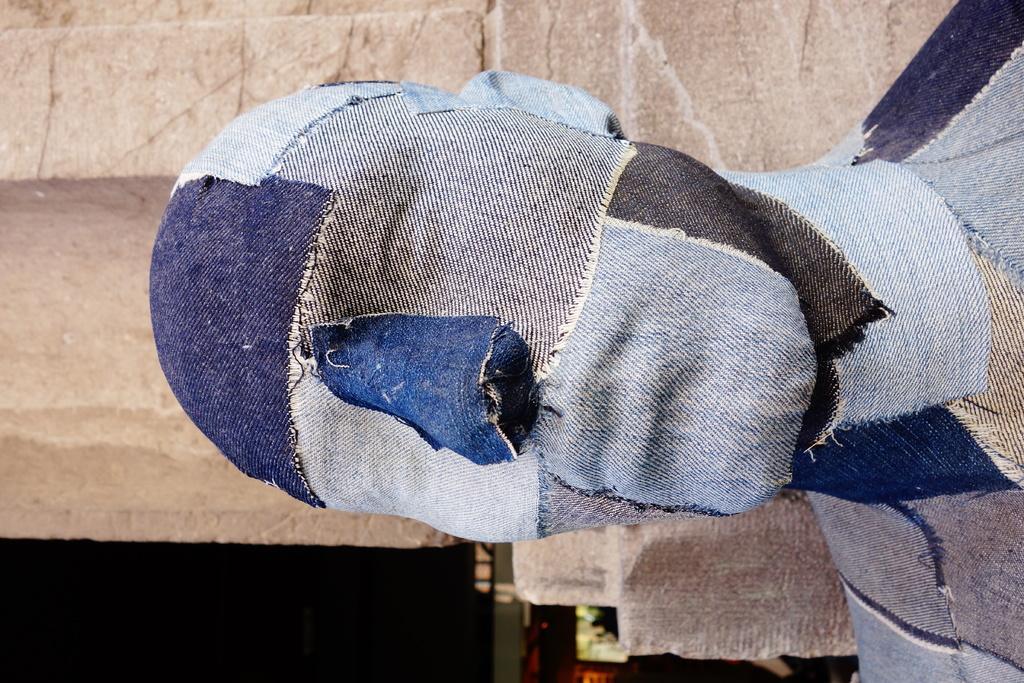Please provide a concise description of this image. This picture is towards the left. Towards the right there is a statue covered with the different colors of cloth. In the background there is a stone wall. 